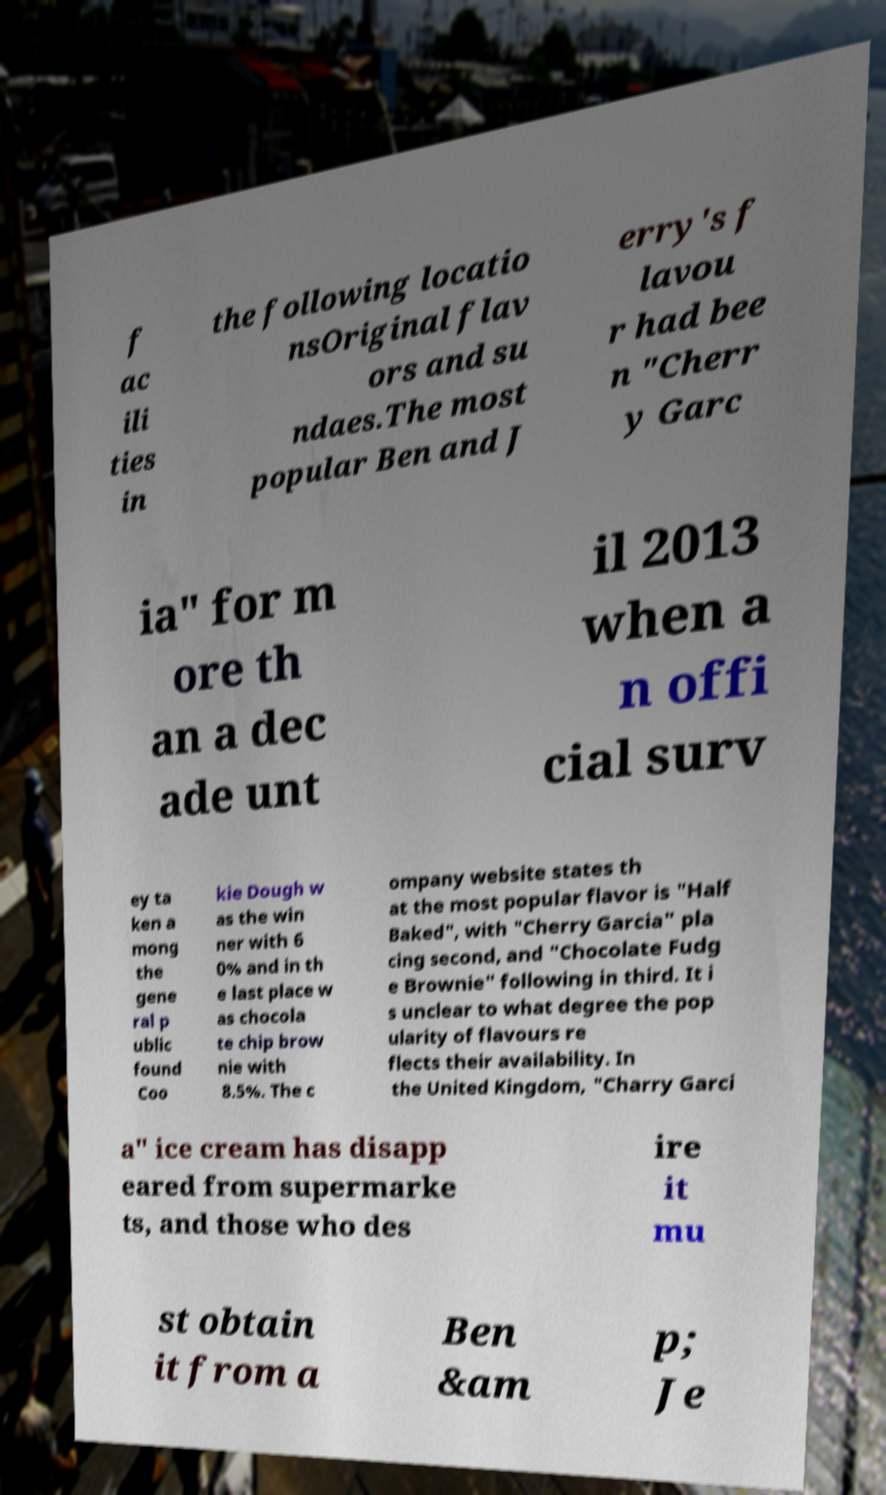Could you extract and type out the text from this image? f ac ili ties in the following locatio nsOriginal flav ors and su ndaes.The most popular Ben and J erry's f lavou r had bee n "Cherr y Garc ia" for m ore th an a dec ade unt il 2013 when a n offi cial surv ey ta ken a mong the gene ral p ublic found Coo kie Dough w as the win ner with 6 0% and in th e last place w as chocola te chip brow nie with 8.5%. The c ompany website states th at the most popular flavor is "Half Baked", with "Cherry Garcia" pla cing second, and "Chocolate Fudg e Brownie" following in third. It i s unclear to what degree the pop ularity of flavours re flects their availability. In the United Kingdom, "Charry Garci a" ice cream has disapp eared from supermarke ts, and those who des ire it mu st obtain it from a Ben &am p; Je 